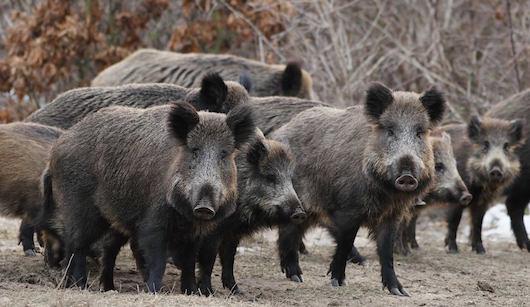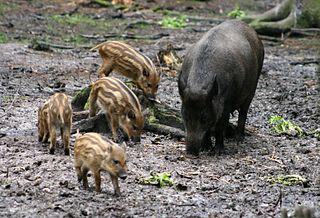The first image is the image on the left, the second image is the image on the right. For the images displayed, is the sentence "Right image includes young hogs with distinctive striped coats." factually correct? Answer yes or no. Yes. The first image is the image on the left, the second image is the image on the right. For the images displayed, is the sentence "A single boar is facing the camera" factually correct? Answer yes or no. No. 